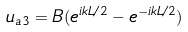<formula> <loc_0><loc_0><loc_500><loc_500>u _ { a 3 } = B ( e ^ { i k L / 2 } - e ^ { - i k L / 2 } )</formula> 